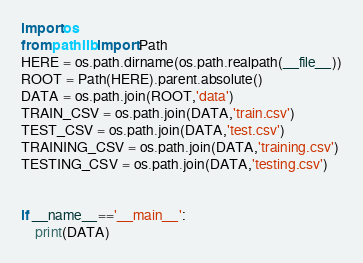Convert code to text. <code><loc_0><loc_0><loc_500><loc_500><_Python_>
import os
from pathlib import Path
HERE = os.path.dirname(os.path.realpath(__file__))
ROOT = Path(HERE).parent.absolute()
DATA = os.path.join(ROOT,'data')
TRAIN_CSV = os.path.join(DATA,'train.csv')
TEST_CSV = os.path.join(DATA,'test.csv')
TRAINING_CSV = os.path.join(DATA,'training.csv')
TESTING_CSV = os.path.join(DATA,'testing.csv')


if __name__=='__main__':
    print(DATA)</code> 